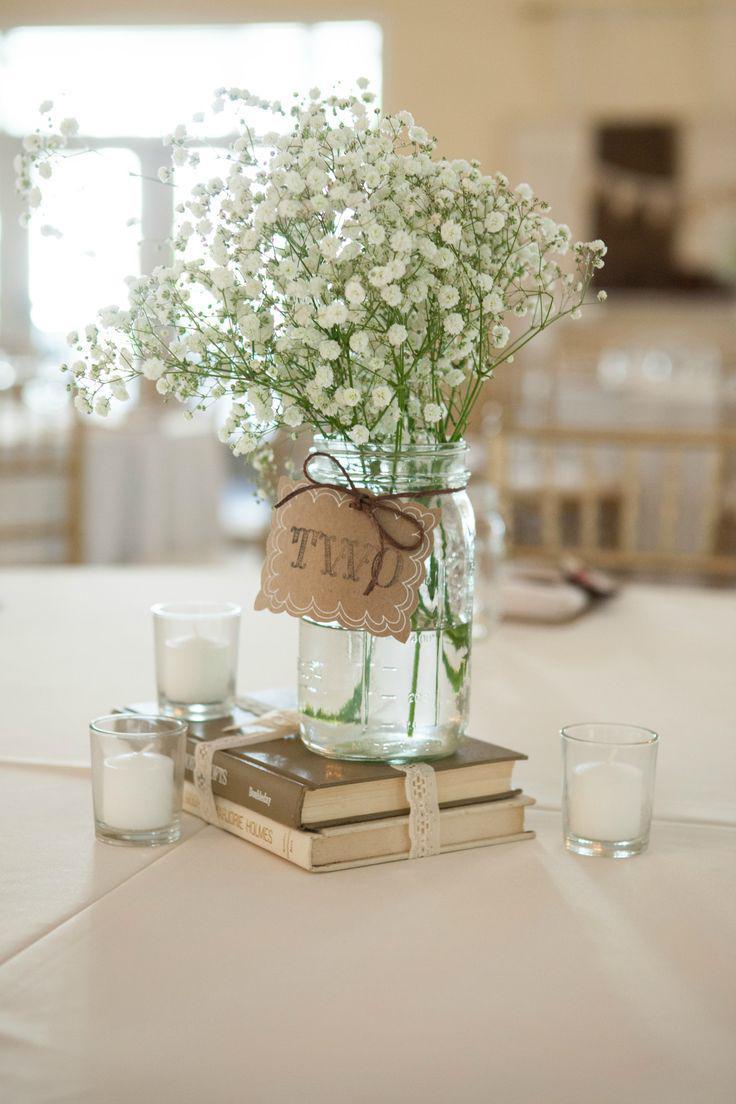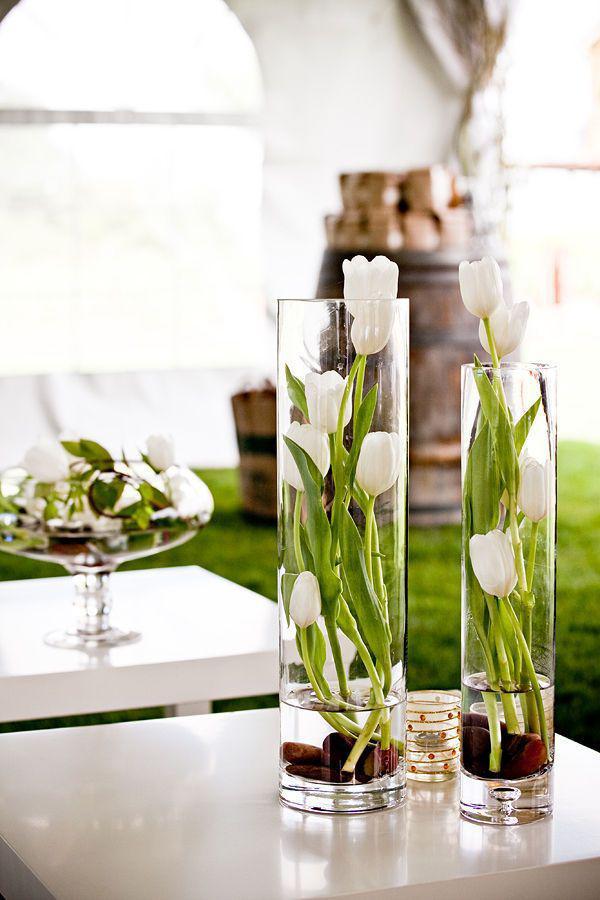The first image is the image on the left, the second image is the image on the right. Assess this claim about the two images: "Both images contain flowering plants in vertical containers.". Correct or not? Answer yes or no. Yes. The first image is the image on the left, the second image is the image on the right. Considering the images on both sides, is "One photo shows at least three exclusively white opaque decorative containers that are not holding flowers." valid? Answer yes or no. No. 